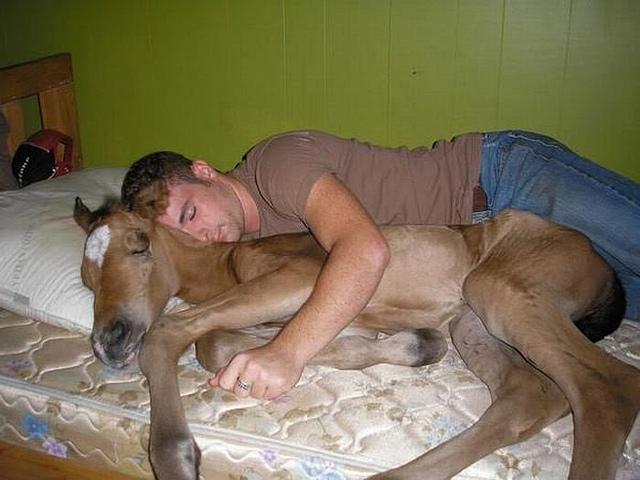What animal is the man cuddling?
Keep it brief. Horse. Is this a human way to treat a horse?
Answer briefly. No. What color is the wall?
Short answer required. Green. 